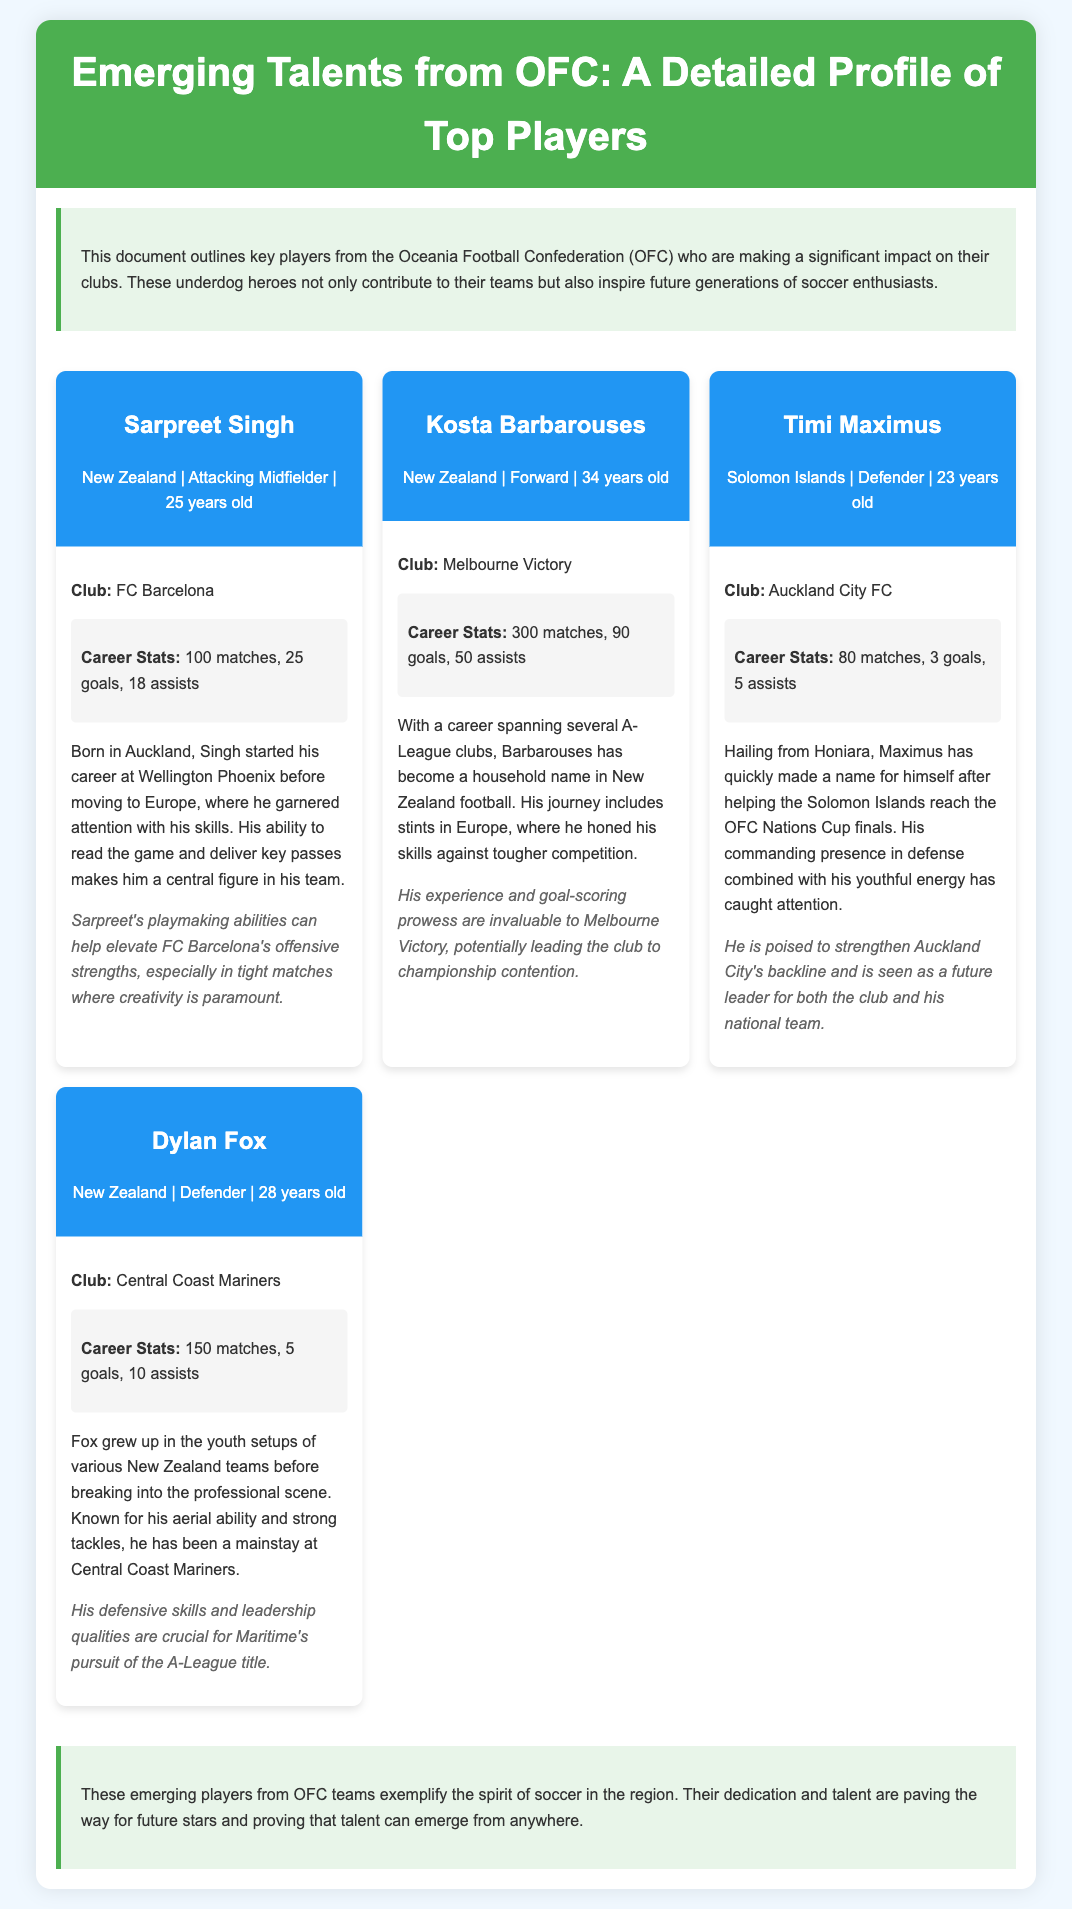What is the age of Sarpreet Singh? Sarpreet Singh is listed as 25 years old in the document.
Answer: 25 years old Which club does Kosta Barbarouses play for? The document states that Kosta Barbarouses plays for Melbourne Victory.
Answer: Melbourne Victory How many goals has Timi Maximus scored in his career? Timi Maximus's career stats indicate he has scored 3 goals.
Answer: 3 goals What position does Dylan Fox play? Dylan Fox is identified as a Defender in the document.
Answer: Defender What is the total number of matches played by Kosta Barbarouses? The document mentions that Kosta Barbarouses has played a total of 300 matches.
Answer: 300 matches Which country does Sarpreet Singh represent? The document indicates that Sarpreet Singh represents New Zealand.
Answer: New Zealand How many assists does Timi Maximus have in his career stats? Timi Maximus's career stats show he has 5 assists.
Answer: 5 assists What significant achievement is mentioned about Timi Maximus? The document states that Timi Maximus helped the Solomon Islands reach the OFC Nations Cup finals.
Answer: Reached the OFC Nations Cup finals What is a key trait of Sarpreet Singh mentioned in the document? The document states that Sarpreet Singh's ability to read the game is a key trait.
Answer: Ability to read the game How is Dylan Fox described in terms of playing style? The document describes Dylan Fox as known for his aerial ability and strong tackles.
Answer: Aerial ability and strong tackles 